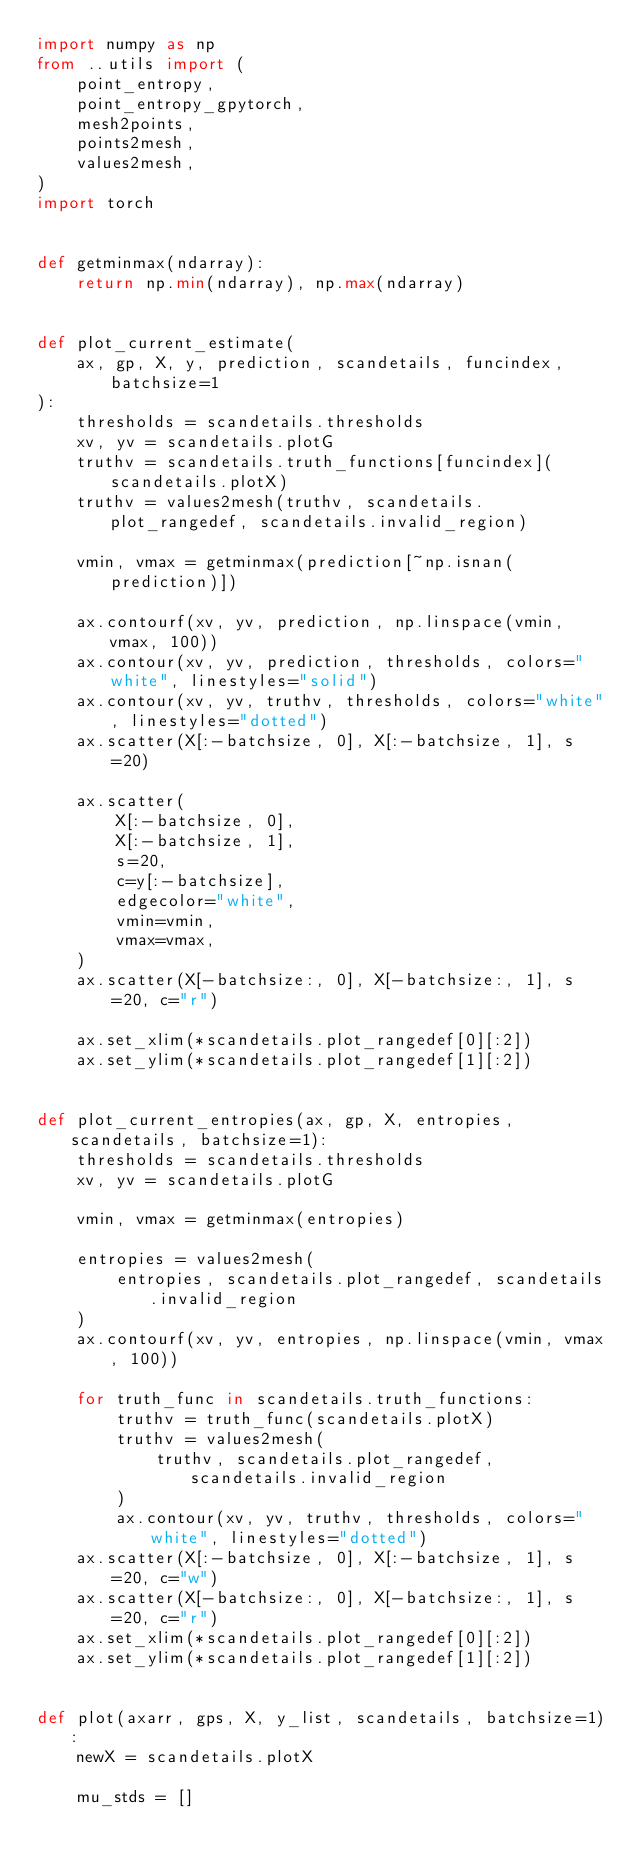Convert code to text. <code><loc_0><loc_0><loc_500><loc_500><_Python_>import numpy as np
from ..utils import (
    point_entropy,
    point_entropy_gpytorch,
    mesh2points,
    points2mesh,
    values2mesh,
)
import torch


def getminmax(ndarray):
    return np.min(ndarray), np.max(ndarray)


def plot_current_estimate(
    ax, gp, X, y, prediction, scandetails, funcindex, batchsize=1
):
    thresholds = scandetails.thresholds
    xv, yv = scandetails.plotG
    truthv = scandetails.truth_functions[funcindex](scandetails.plotX)
    truthv = values2mesh(truthv, scandetails.plot_rangedef, scandetails.invalid_region)

    vmin, vmax = getminmax(prediction[~np.isnan(prediction)])

    ax.contourf(xv, yv, prediction, np.linspace(vmin, vmax, 100))
    ax.contour(xv, yv, prediction, thresholds, colors="white", linestyles="solid")
    ax.contour(xv, yv, truthv, thresholds, colors="white", linestyles="dotted")
    ax.scatter(X[:-batchsize, 0], X[:-batchsize, 1], s=20)

    ax.scatter(
        X[:-batchsize, 0],
        X[:-batchsize, 1],
        s=20,
        c=y[:-batchsize],
        edgecolor="white",
        vmin=vmin,
        vmax=vmax,
    )
    ax.scatter(X[-batchsize:, 0], X[-batchsize:, 1], s=20, c="r")

    ax.set_xlim(*scandetails.plot_rangedef[0][:2])
    ax.set_ylim(*scandetails.plot_rangedef[1][:2])


def plot_current_entropies(ax, gp, X, entropies, scandetails, batchsize=1):
    thresholds = scandetails.thresholds
    xv, yv = scandetails.plotG

    vmin, vmax = getminmax(entropies)

    entropies = values2mesh(
        entropies, scandetails.plot_rangedef, scandetails.invalid_region
    )
    ax.contourf(xv, yv, entropies, np.linspace(vmin, vmax, 100))

    for truth_func in scandetails.truth_functions:
        truthv = truth_func(scandetails.plotX)
        truthv = values2mesh(
            truthv, scandetails.plot_rangedef, scandetails.invalid_region
        )
        ax.contour(xv, yv, truthv, thresholds, colors="white", linestyles="dotted")
    ax.scatter(X[:-batchsize, 0], X[:-batchsize, 1], s=20, c="w")
    ax.scatter(X[-batchsize:, 0], X[-batchsize:, 1], s=20, c="r")
    ax.set_xlim(*scandetails.plot_rangedef[0][:2])
    ax.set_ylim(*scandetails.plot_rangedef[1][:2])


def plot(axarr, gps, X, y_list, scandetails, batchsize=1):
    newX = scandetails.plotX

    mu_stds = []</code> 